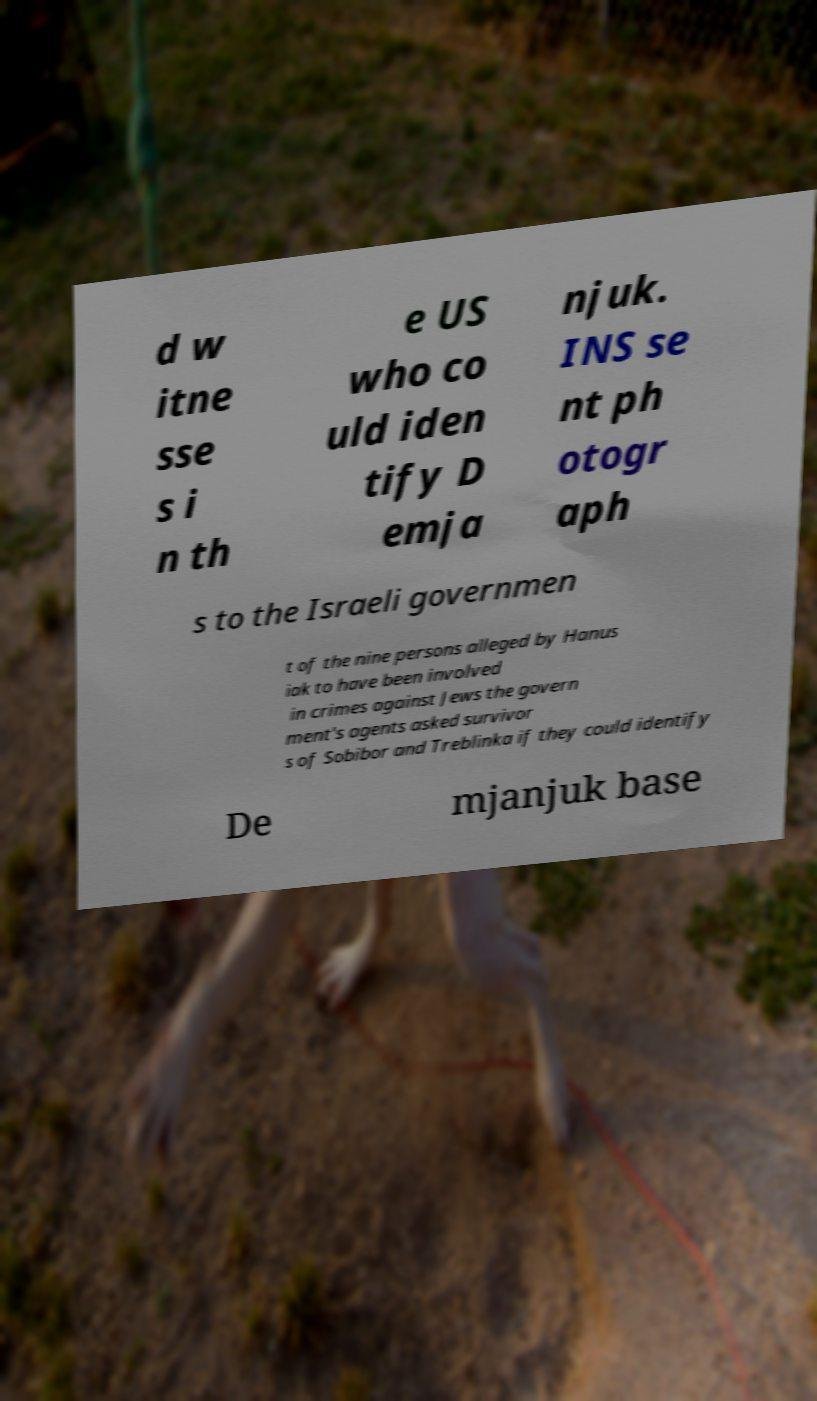I need the written content from this picture converted into text. Can you do that? d w itne sse s i n th e US who co uld iden tify D emja njuk. INS se nt ph otogr aph s to the Israeli governmen t of the nine persons alleged by Hanus iak to have been involved in crimes against Jews the govern ment's agents asked survivor s of Sobibor and Treblinka if they could identify De mjanjuk base 